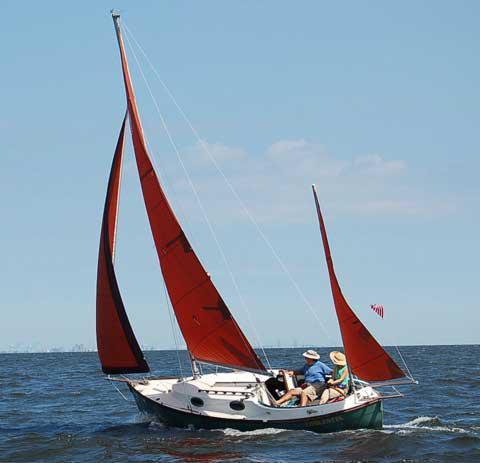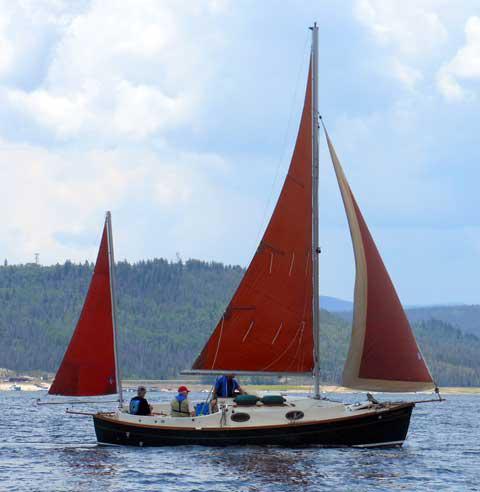The first image is the image on the left, the second image is the image on the right. Analyze the images presented: Is the assertion "In at least one image shows a boat with a visible name on its hull." valid? Answer yes or no. No. The first image is the image on the left, the second image is the image on the right. For the images displayed, is the sentence "There is a sailboat out in open water in the center of both images." factually correct? Answer yes or no. Yes. 